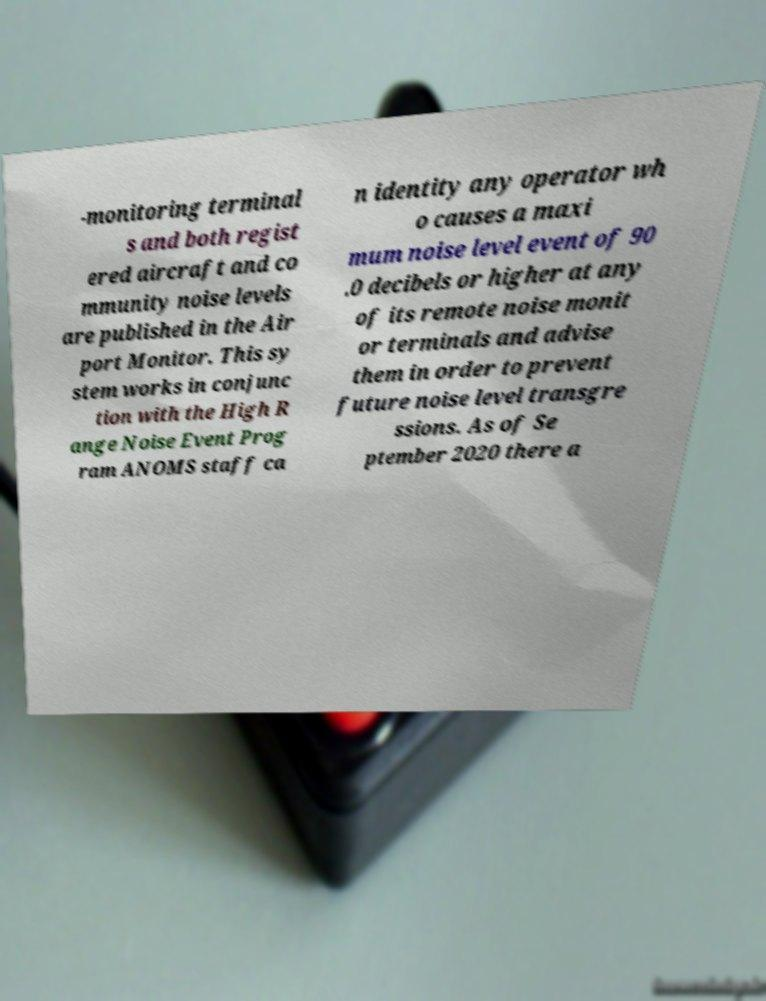For documentation purposes, I need the text within this image transcribed. Could you provide that? -monitoring terminal s and both regist ered aircraft and co mmunity noise levels are published in the Air port Monitor. This sy stem works in conjunc tion with the High R ange Noise Event Prog ram ANOMS staff ca n identity any operator wh o causes a maxi mum noise level event of 90 .0 decibels or higher at any of its remote noise monit or terminals and advise them in order to prevent future noise level transgre ssions. As of Se ptember 2020 there a 